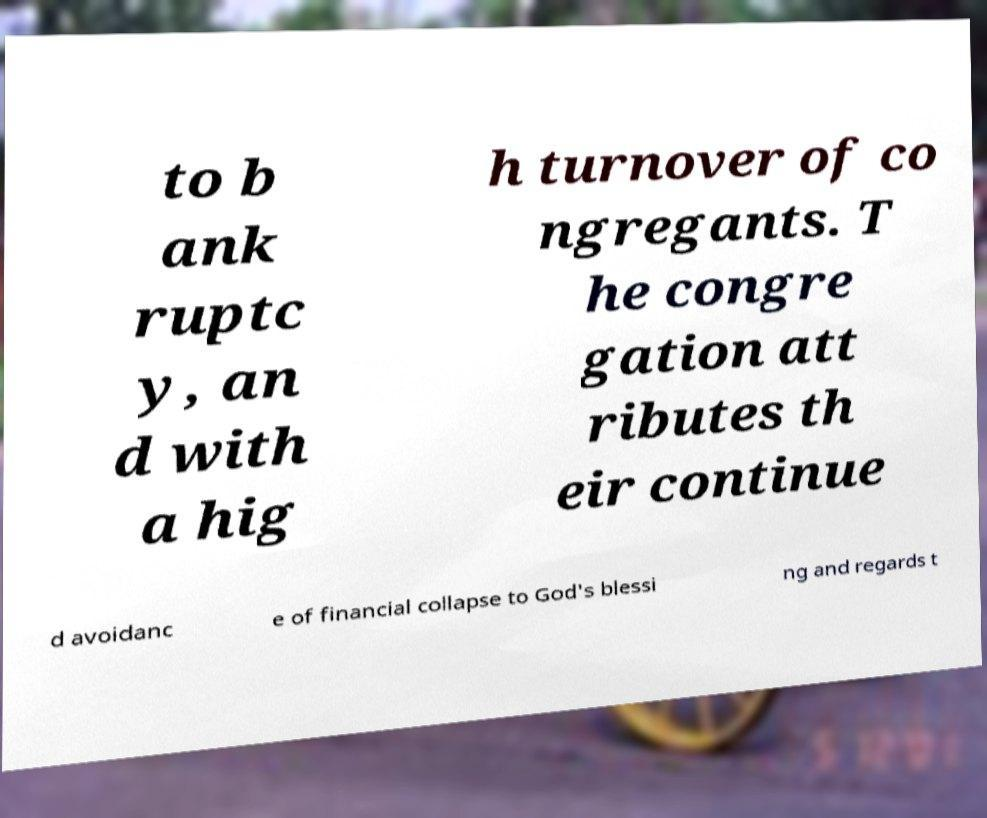Could you extract and type out the text from this image? to b ank ruptc y, an d with a hig h turnover of co ngregants. T he congre gation att ributes th eir continue d avoidanc e of financial collapse to God's blessi ng and regards t 